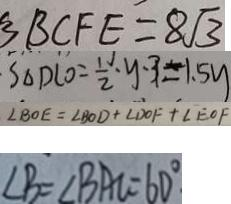<formula> <loc_0><loc_0><loc_500><loc_500>B B C F E = 8 \sqrt { 3 } 
 \cdot S _ { \Delta } D C O = \frac { 1 } { 2 } \cdot y \cdot 3 = 1 . 5 y 
 \angle B O E = \angle B O D + \angle D O F + \angle E O F 
 \angle B = \angle B A C = 6 0 ^ { \circ }</formula> 